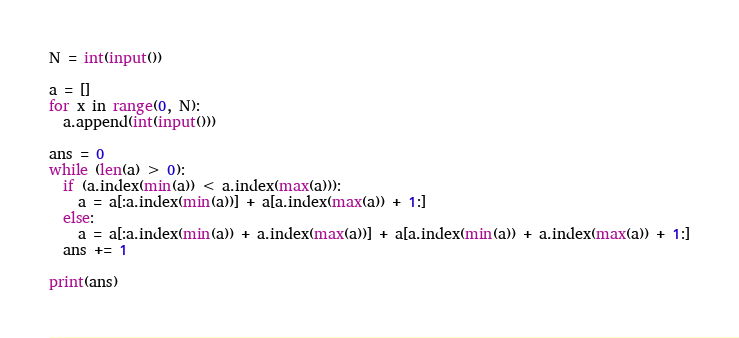Convert code to text. <code><loc_0><loc_0><loc_500><loc_500><_Python_>N = int(input())

a = []
for x in range(0, N):
  a.append(int(input()))

ans = 0
while (len(a) > 0):
  if (a.index(min(a)) < a.index(max(a))):
    a = a[:a.index(min(a))] + a[a.index(max(a)) + 1:]
  else:
    a = a[:a.index(min(a)) + a.index(max(a))] + a[a.index(min(a)) + a.index(max(a)) + 1:]
  ans += 1

print(ans)</code> 